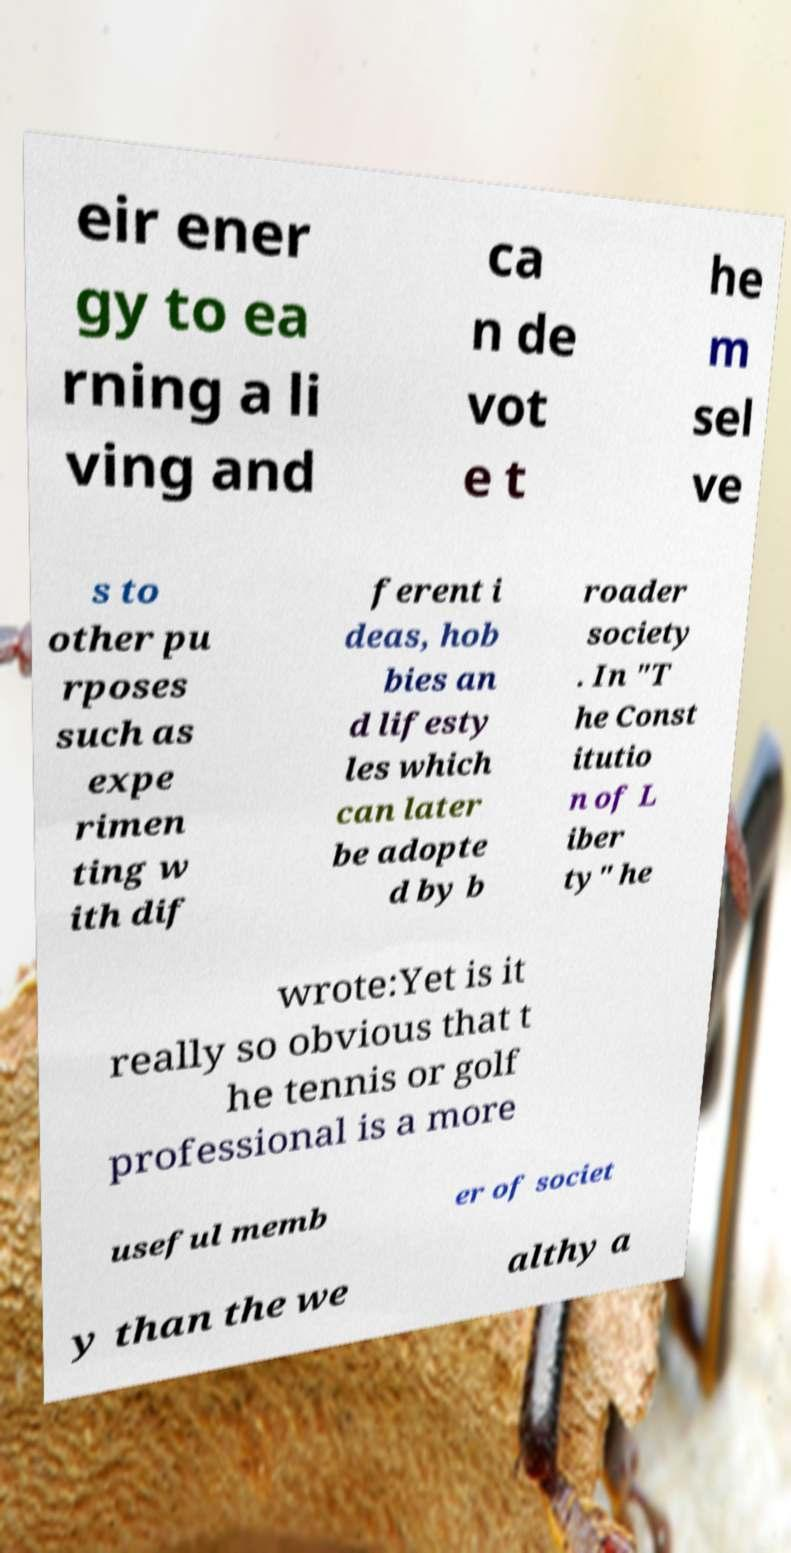Please read and relay the text visible in this image. What does it say? eir ener gy to ea rning a li ving and ca n de vot e t he m sel ve s to other pu rposes such as expe rimen ting w ith dif ferent i deas, hob bies an d lifesty les which can later be adopte d by b roader society . In "T he Const itutio n of L iber ty" he wrote:Yet is it really so obvious that t he tennis or golf professional is a more useful memb er of societ y than the we althy a 